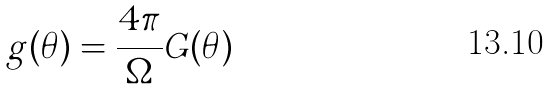Convert formula to latex. <formula><loc_0><loc_0><loc_500><loc_500>g ( \theta ) = \frac { 4 \pi } { \Omega } G ( \theta )</formula> 